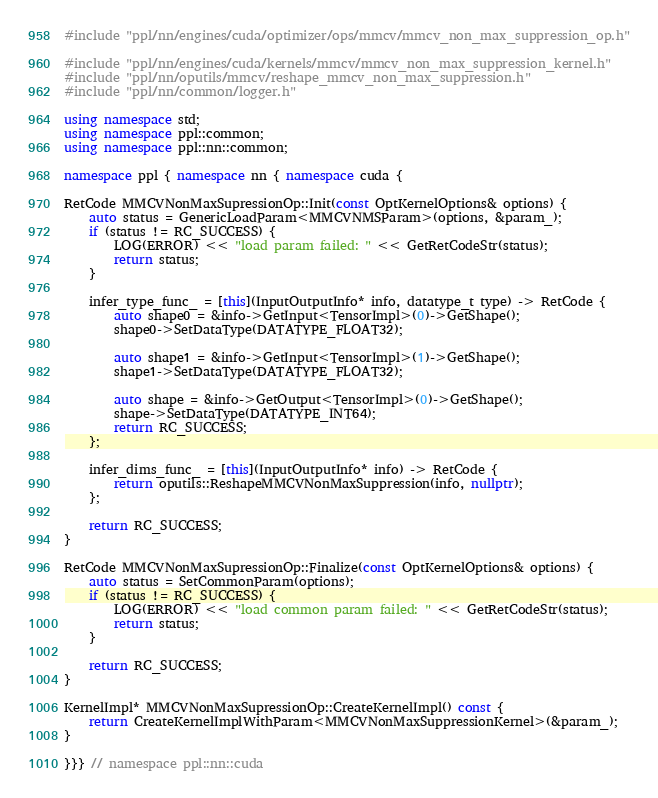Convert code to text. <code><loc_0><loc_0><loc_500><loc_500><_C++_>#include "ppl/nn/engines/cuda/optimizer/ops/mmcv/mmcv_non_max_suppression_op.h"

#include "ppl/nn/engines/cuda/kernels/mmcv/mmcv_non_max_suppression_kernel.h"
#include "ppl/nn/oputils/mmcv/reshape_mmcv_non_max_suppression.h"
#include "ppl/nn/common/logger.h"

using namespace std;
using namespace ppl::common;
using namespace ppl::nn::common;

namespace ppl { namespace nn { namespace cuda {

RetCode MMCVNonMaxSupressionOp::Init(const OptKernelOptions& options) {
    auto status = GenericLoadParam<MMCVNMSParam>(options, &param_);
    if (status != RC_SUCCESS) {
        LOG(ERROR) << "load param failed: " << GetRetCodeStr(status);
        return status;
    }

    infer_type_func_ = [this](InputOutputInfo* info, datatype_t type) -> RetCode {
        auto shape0 = &info->GetInput<TensorImpl>(0)->GetShape();
        shape0->SetDataType(DATATYPE_FLOAT32);

        auto shape1 = &info->GetInput<TensorImpl>(1)->GetShape();
        shape1->SetDataType(DATATYPE_FLOAT32);

        auto shape = &info->GetOutput<TensorImpl>(0)->GetShape();
        shape->SetDataType(DATATYPE_INT64);
        return RC_SUCCESS;
    };

    infer_dims_func_ = [this](InputOutputInfo* info) -> RetCode {
        return oputils::ReshapeMMCVNonMaxSuppression(info, nullptr);
    };

    return RC_SUCCESS;
}

RetCode MMCVNonMaxSupressionOp::Finalize(const OptKernelOptions& options) {
    auto status = SetCommonParam(options);
    if (status != RC_SUCCESS) {
        LOG(ERROR) << "load common param failed: " << GetRetCodeStr(status);
        return status;
    }

    return RC_SUCCESS;
}

KernelImpl* MMCVNonMaxSupressionOp::CreateKernelImpl() const {
    return CreateKernelImplWithParam<MMCVNonMaxSuppressionKernel>(&param_);
}

}}} // namespace ppl::nn::cuda
</code> 